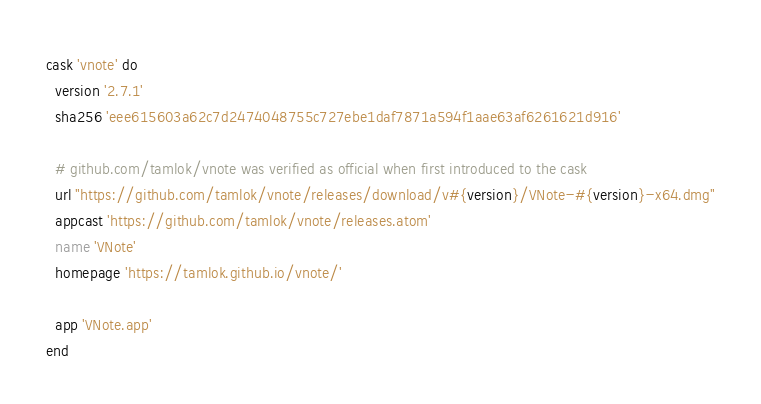<code> <loc_0><loc_0><loc_500><loc_500><_Ruby_>cask 'vnote' do
  version '2.7.1'
  sha256 'eee615603a62c7d2474048755c727ebe1daf7871a594f1aae63af6261621d916'

  # github.com/tamlok/vnote was verified as official when first introduced to the cask
  url "https://github.com/tamlok/vnote/releases/download/v#{version}/VNote-#{version}-x64.dmg"
  appcast 'https://github.com/tamlok/vnote/releases.atom'
  name 'VNote'
  homepage 'https://tamlok.github.io/vnote/'

  app 'VNote.app'
end
</code> 